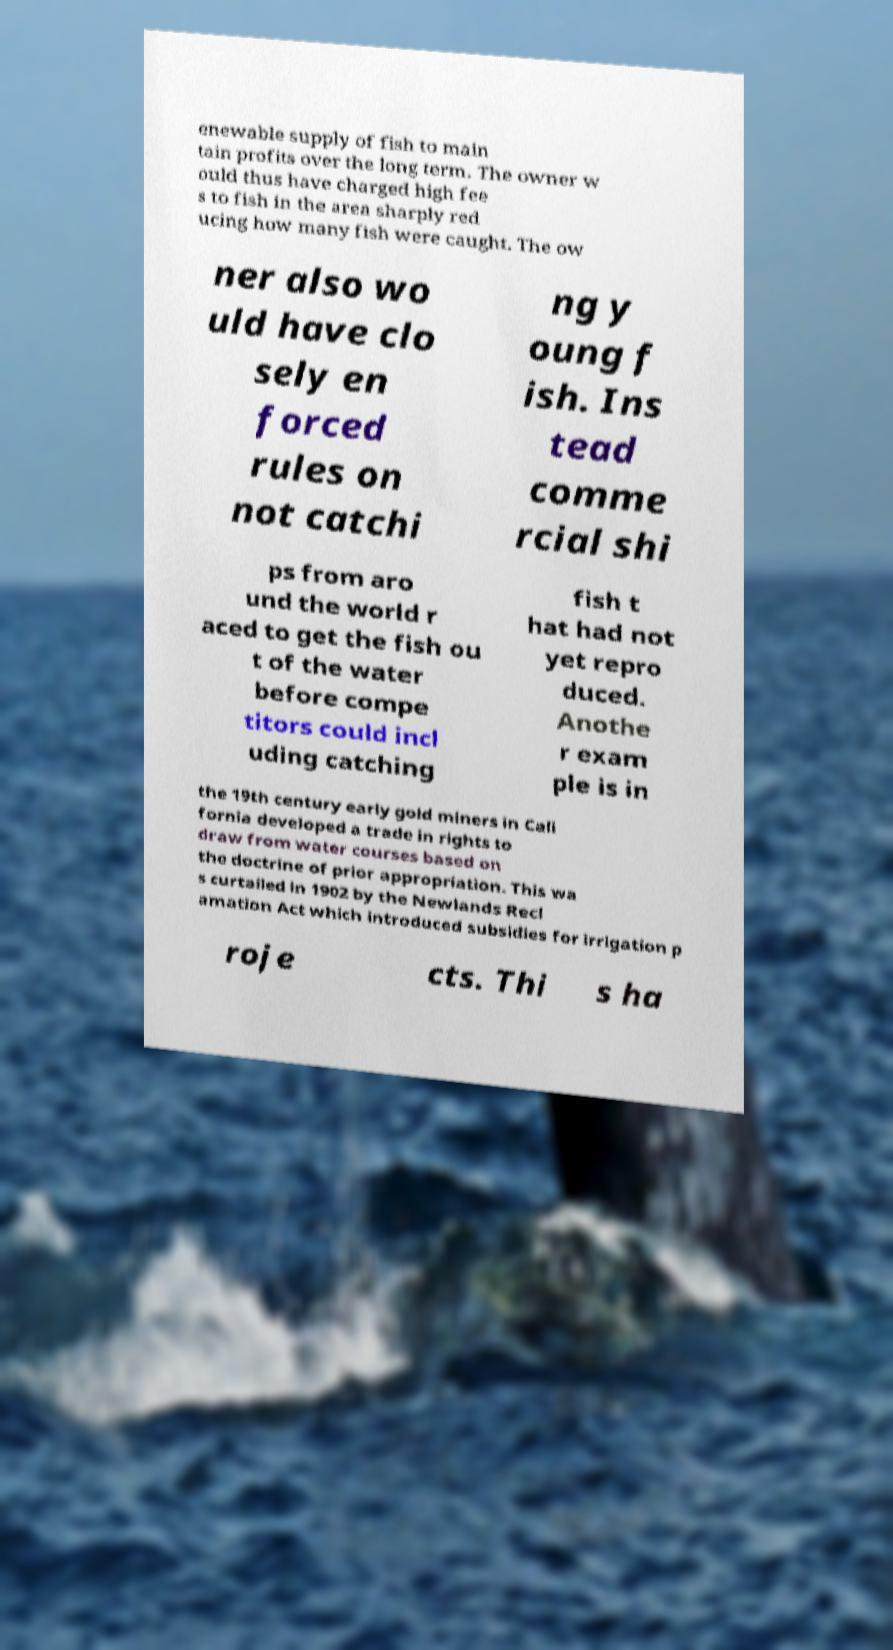For documentation purposes, I need the text within this image transcribed. Could you provide that? enewable supply of fish to main tain profits over the long term. The owner w ould thus have charged high fee s to fish in the area sharply red ucing how many fish were caught. The ow ner also wo uld have clo sely en forced rules on not catchi ng y oung f ish. Ins tead comme rcial shi ps from aro und the world r aced to get the fish ou t of the water before compe titors could incl uding catching fish t hat had not yet repro duced. Anothe r exam ple is in the 19th century early gold miners in Cali fornia developed a trade in rights to draw from water courses based on the doctrine of prior appropriation. This wa s curtailed in 1902 by the Newlands Recl amation Act which introduced subsidies for irrigation p roje cts. Thi s ha 